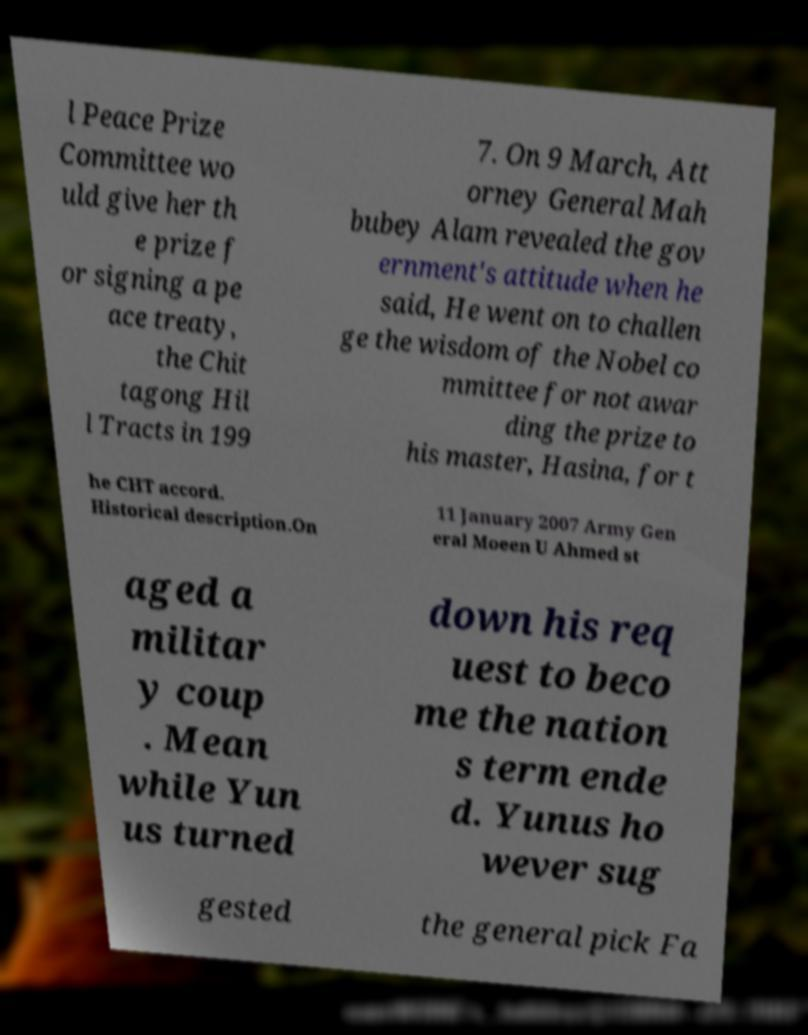What messages or text are displayed in this image? I need them in a readable, typed format. l Peace Prize Committee wo uld give her th e prize f or signing a pe ace treaty, the Chit tagong Hil l Tracts in 199 7. On 9 March, Att orney General Mah bubey Alam revealed the gov ernment's attitude when he said, He went on to challen ge the wisdom of the Nobel co mmittee for not awar ding the prize to his master, Hasina, for t he CHT accord. Historical description.On 11 January 2007 Army Gen eral Moeen U Ahmed st aged a militar y coup . Mean while Yun us turned down his req uest to beco me the nation s term ende d. Yunus ho wever sug gested the general pick Fa 